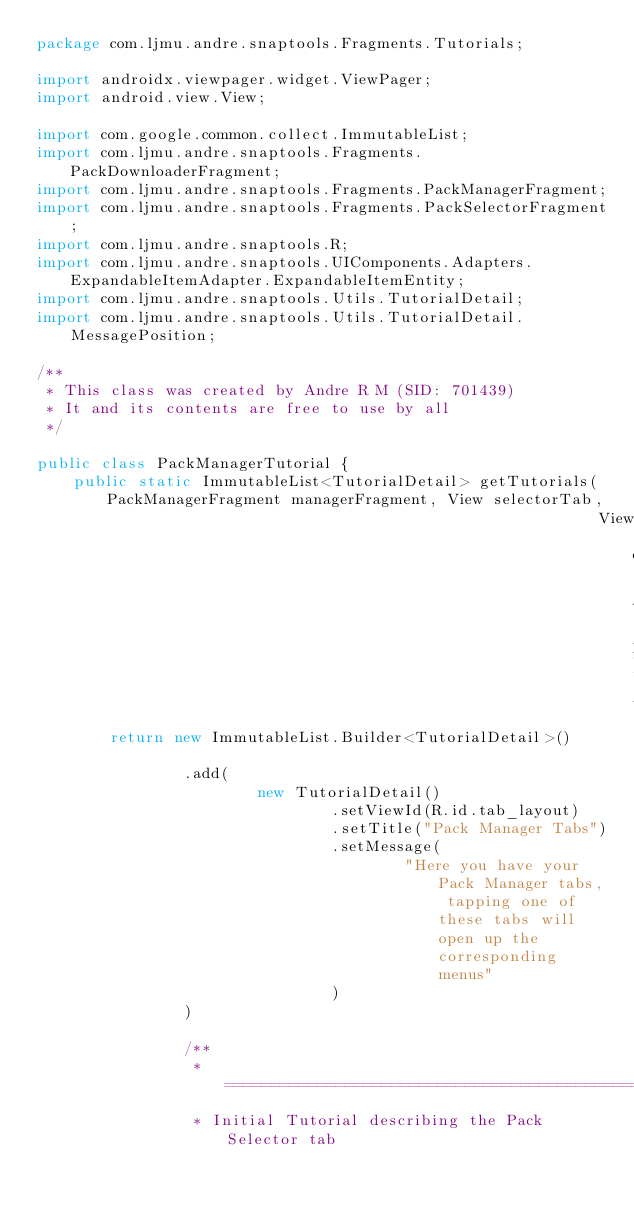Convert code to text. <code><loc_0><loc_0><loc_500><loc_500><_Java_>package com.ljmu.andre.snaptools.Fragments.Tutorials;

import androidx.viewpager.widget.ViewPager;
import android.view.View;

import com.google.common.collect.ImmutableList;
import com.ljmu.andre.snaptools.Fragments.PackDownloaderFragment;
import com.ljmu.andre.snaptools.Fragments.PackManagerFragment;
import com.ljmu.andre.snaptools.Fragments.PackSelectorFragment;
import com.ljmu.andre.snaptools.R;
import com.ljmu.andre.snaptools.UIComponents.Adapters.ExpandableItemAdapter.ExpandableItemEntity;
import com.ljmu.andre.snaptools.Utils.TutorialDetail;
import com.ljmu.andre.snaptools.Utils.TutorialDetail.MessagePosition;

/**
 * This class was created by Andre R M (SID: 701439)
 * It and its contents are free to use by all
 */

public class PackManagerTutorial {
    public static ImmutableList<TutorialDetail> getTutorials(PackManagerFragment managerFragment, View selectorTab,
                                                             View downloaderTab, ViewPager pager) {
        return new ImmutableList.Builder<TutorialDetail>()

                .add(
                        new TutorialDetail()
                                .setViewId(R.id.tab_layout)
                                .setTitle("Pack Manager Tabs")
                                .setMessage(
                                        "Here you have your Pack Manager tabs, tapping one of these tabs will open up the corresponding menus"
                                )
                )

                /**
                 * ===========================================================================
                 * Initial Tutorial describing the Pack Selector tab</code> 